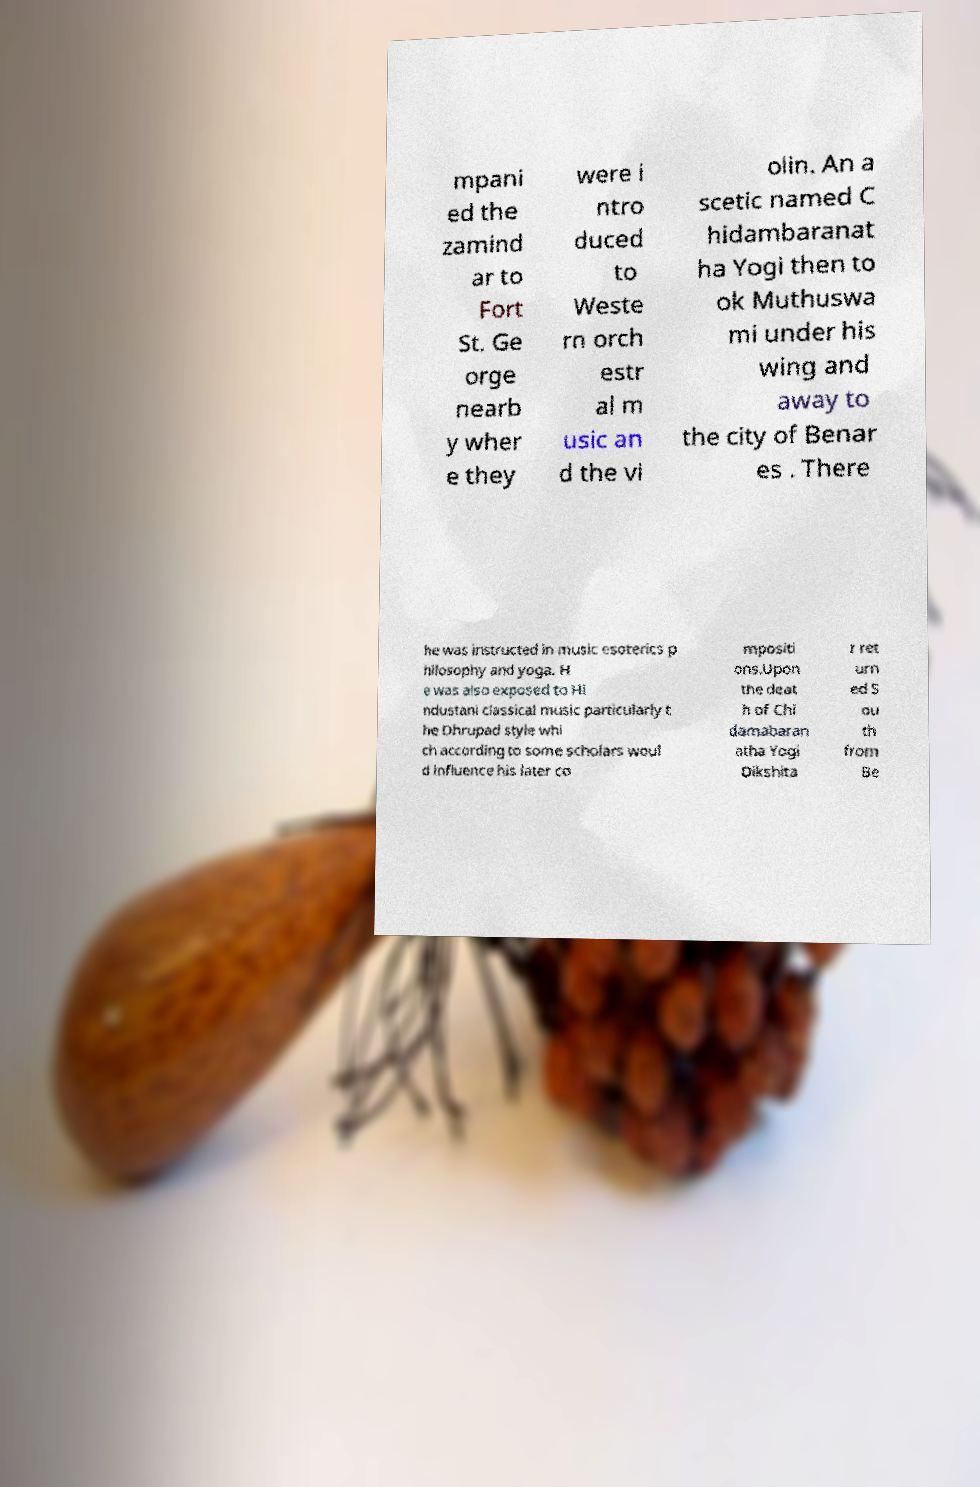Can you accurately transcribe the text from the provided image for me? mpani ed the zamind ar to Fort St. Ge orge nearb y wher e they were i ntro duced to Weste rn orch estr al m usic an d the vi olin. An a scetic named C hidambaranat ha Yogi then to ok Muthuswa mi under his wing and away to the city of Benar es . There he was instructed in music esoterics p hilosophy and yoga. H e was also exposed to Hi ndustani classical music particularly t he Dhrupad style whi ch according to some scholars woul d influence his later co mpositi ons.Upon the deat h of Chi damabaran atha Yogi Dikshita r ret urn ed S ou th from Be 